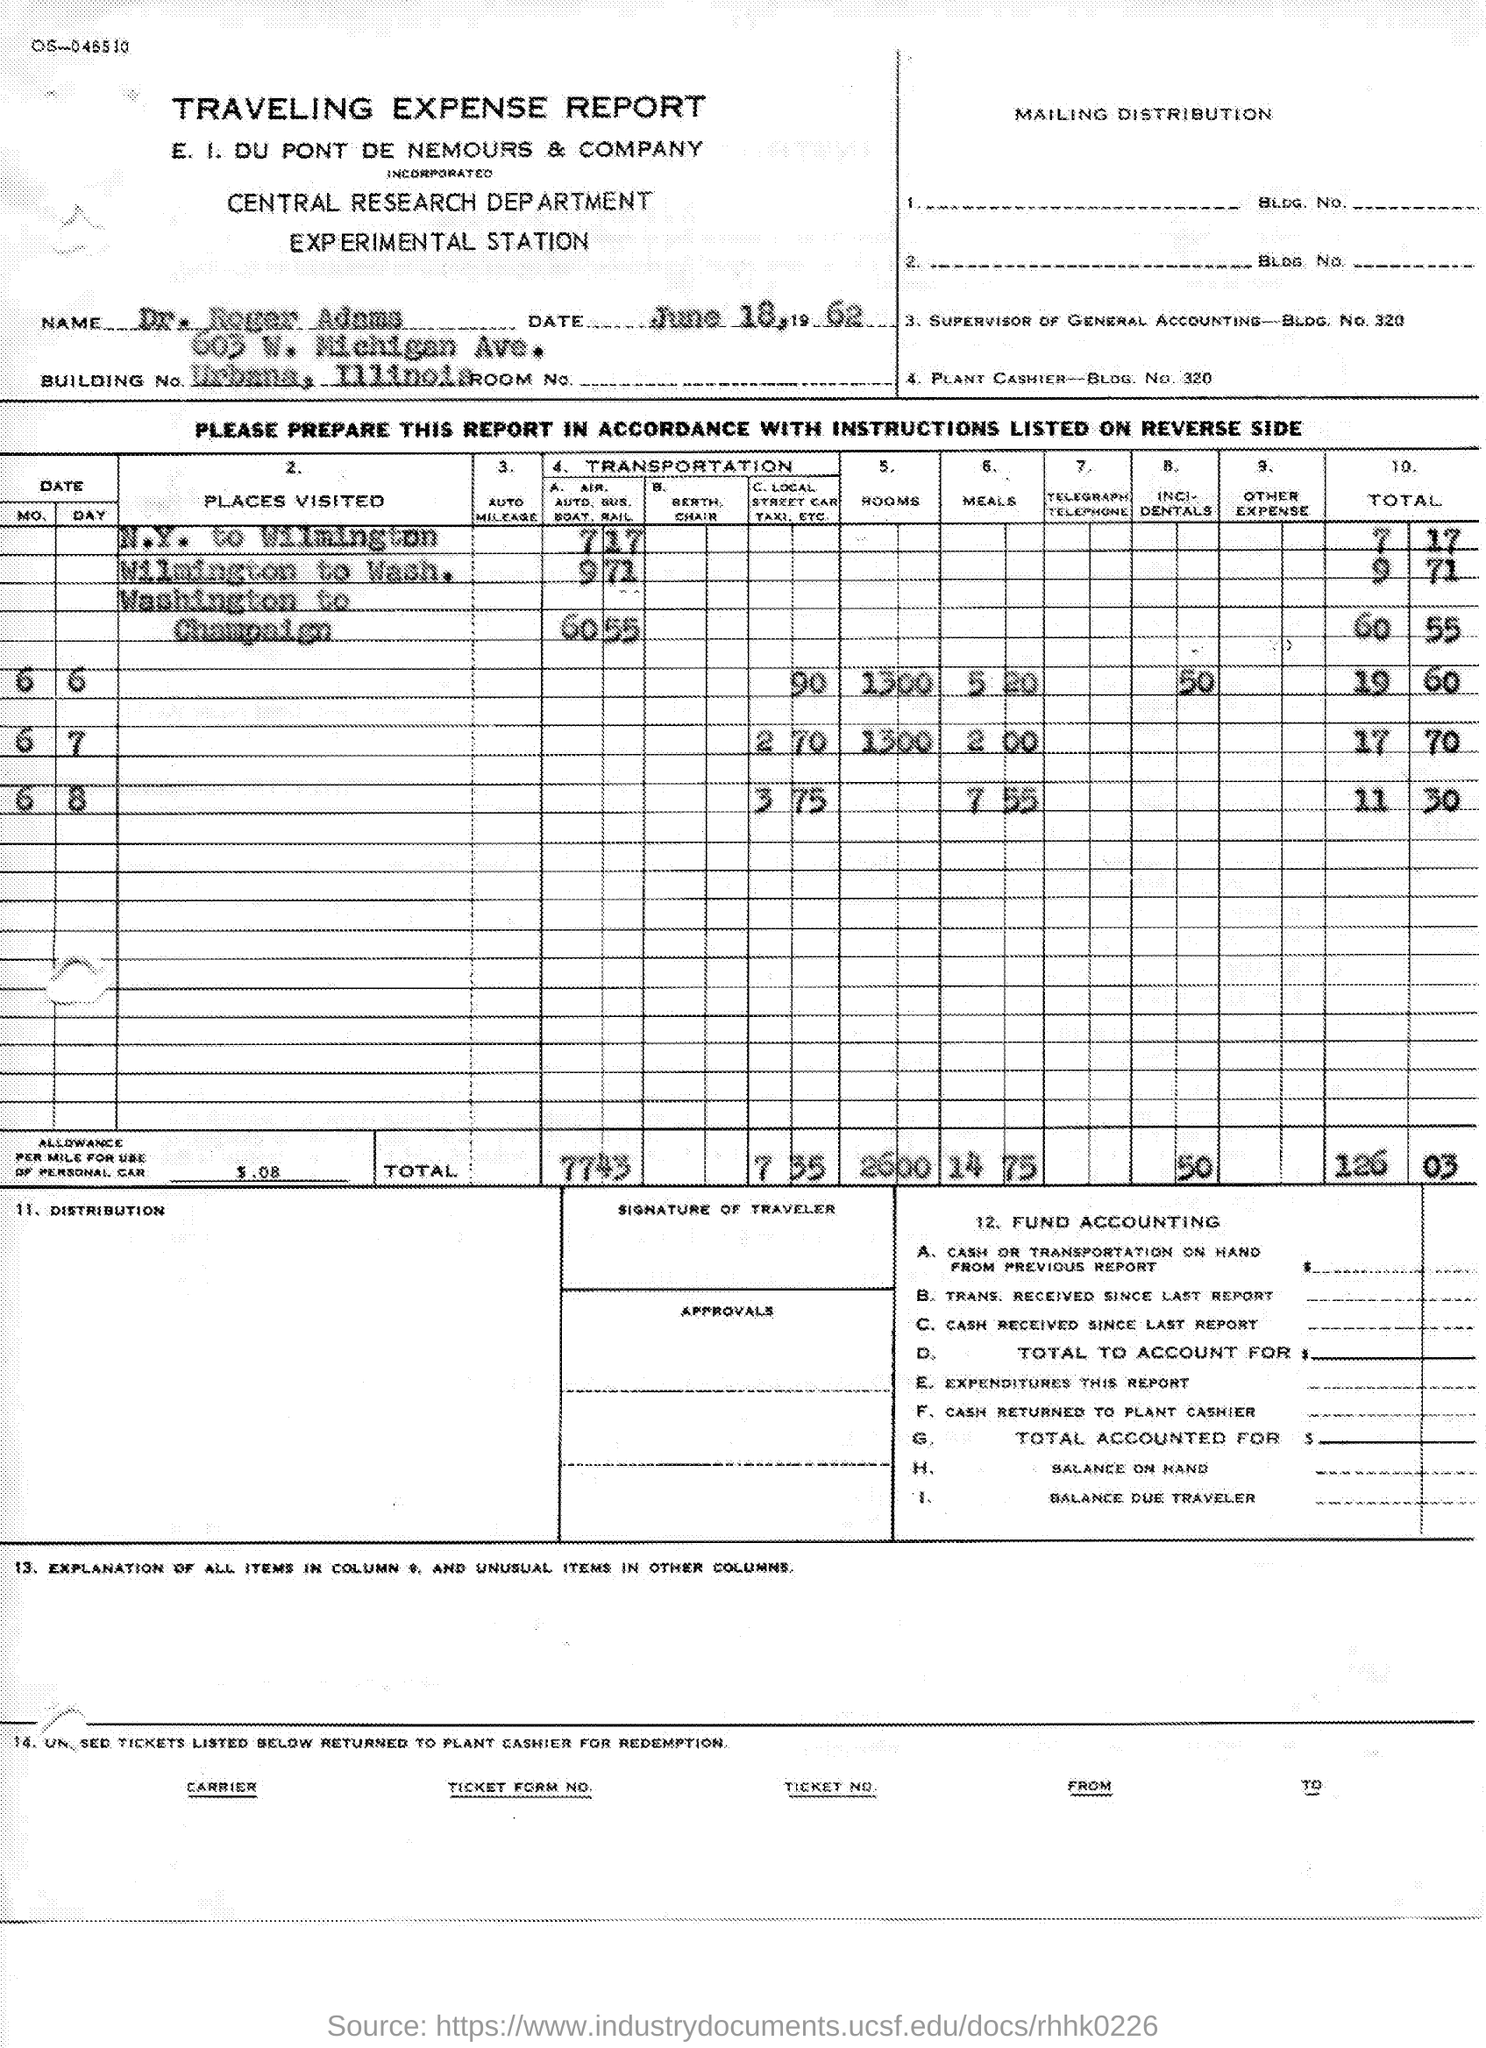Highlight a few significant elements in this photo. The date is June 18, 1962. Dr. Roger Adams is the name. The title of the document is a Traveling Expense Report. 